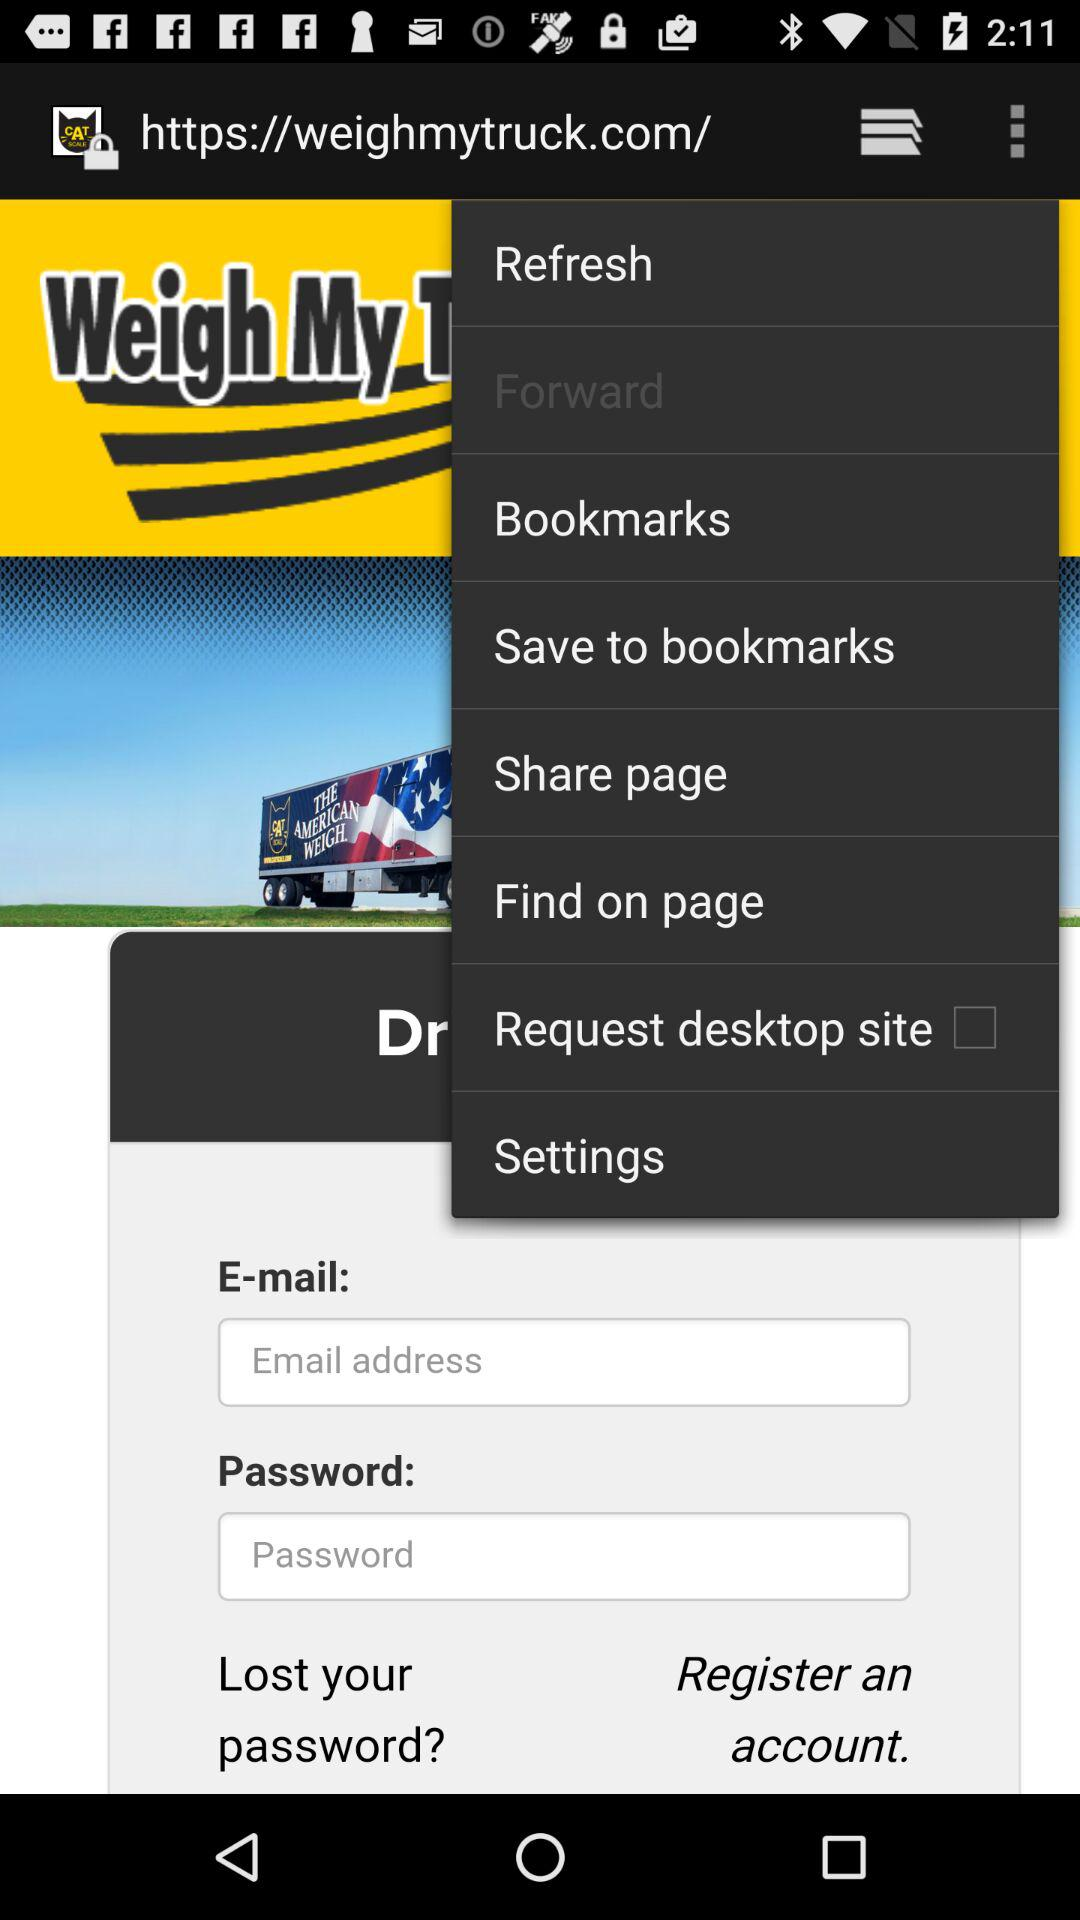What is the status of the "Request desktop site" setting? The status is "off". 